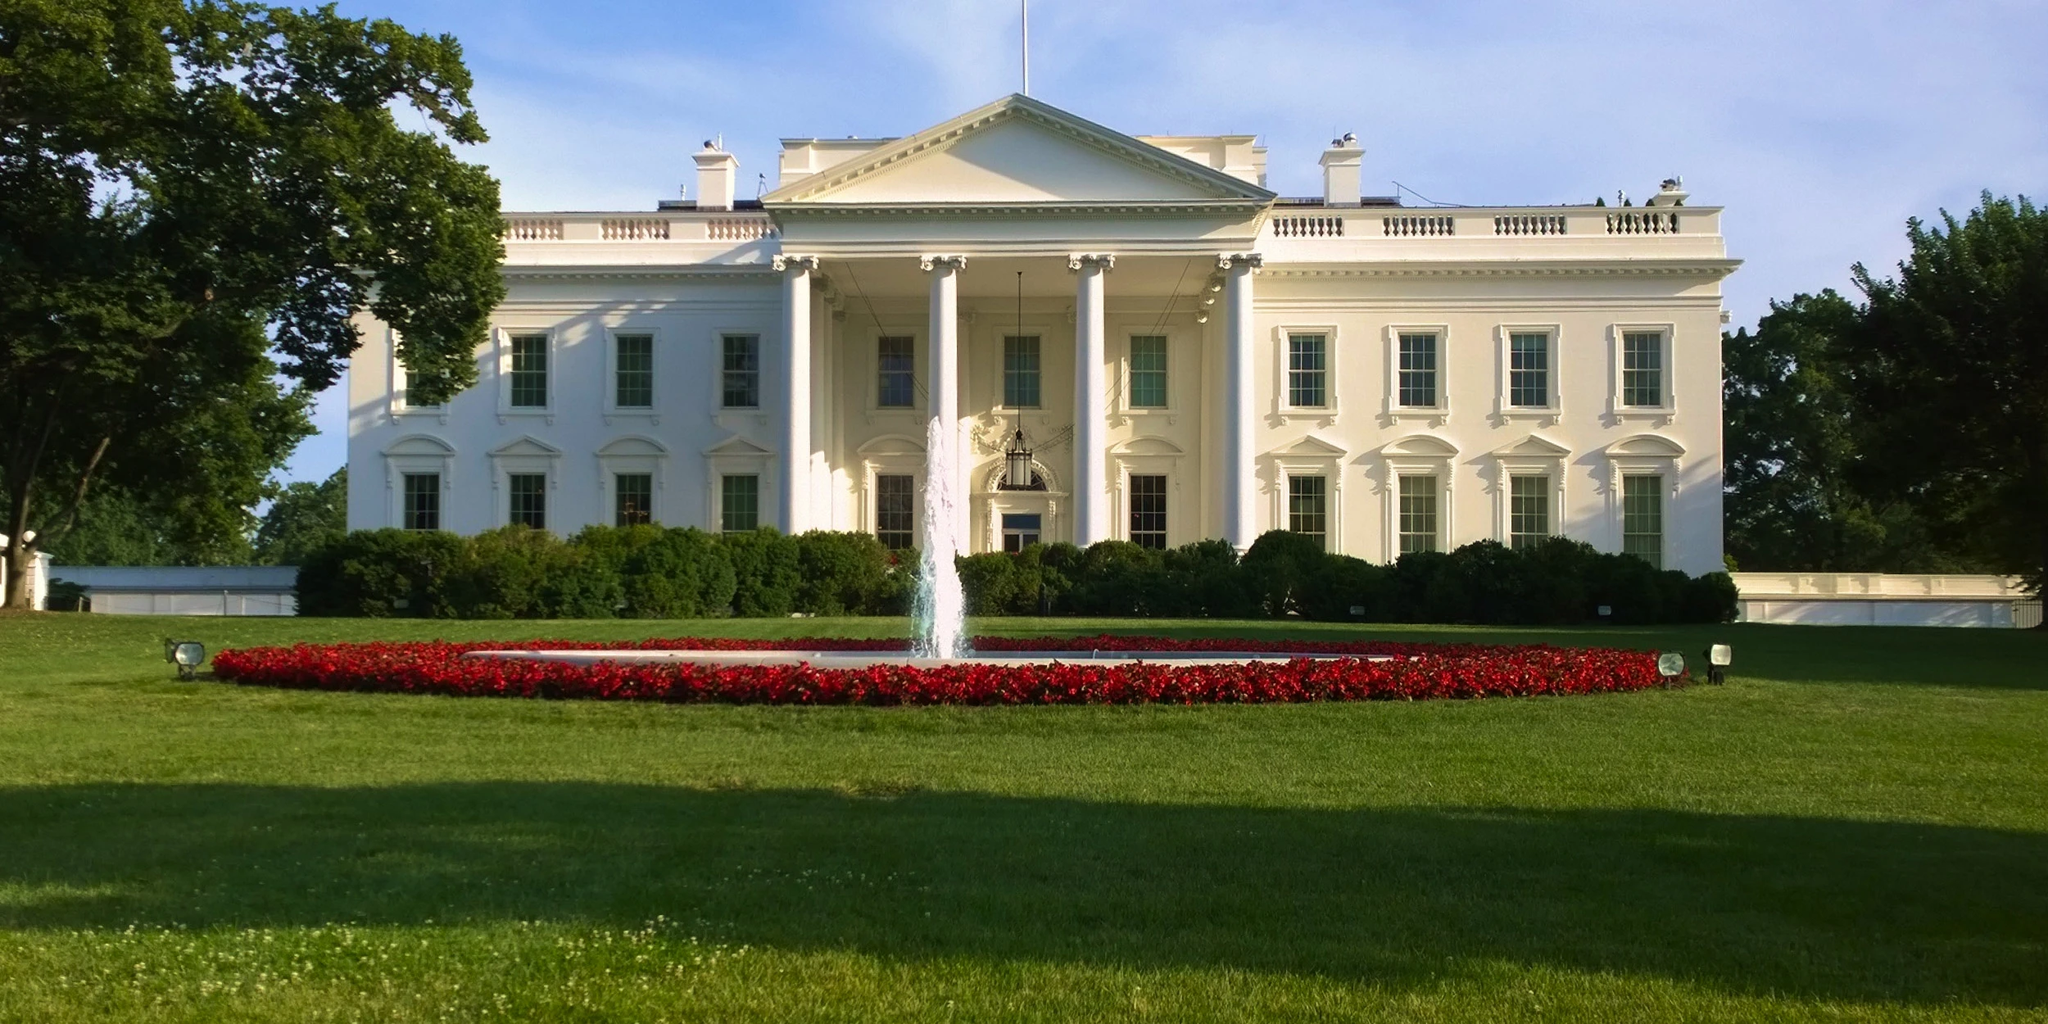What is this photo about'? The image captures the iconic White House, the official residence and workplace of the president of the United States. The neoclassical facade of the building, painted in its signature white, stands out against the clear sky. The structure is adorned with columns and a portico, adding to its grandeur. The perspective from the front lawn offers a view of the well-manicured greenery that surrounds the building. A fountain, gushing with water, is situated on the lawn, surrounded by vibrant red flowers. The overall image presents a serene and majestic view of this worldwide landmark. 